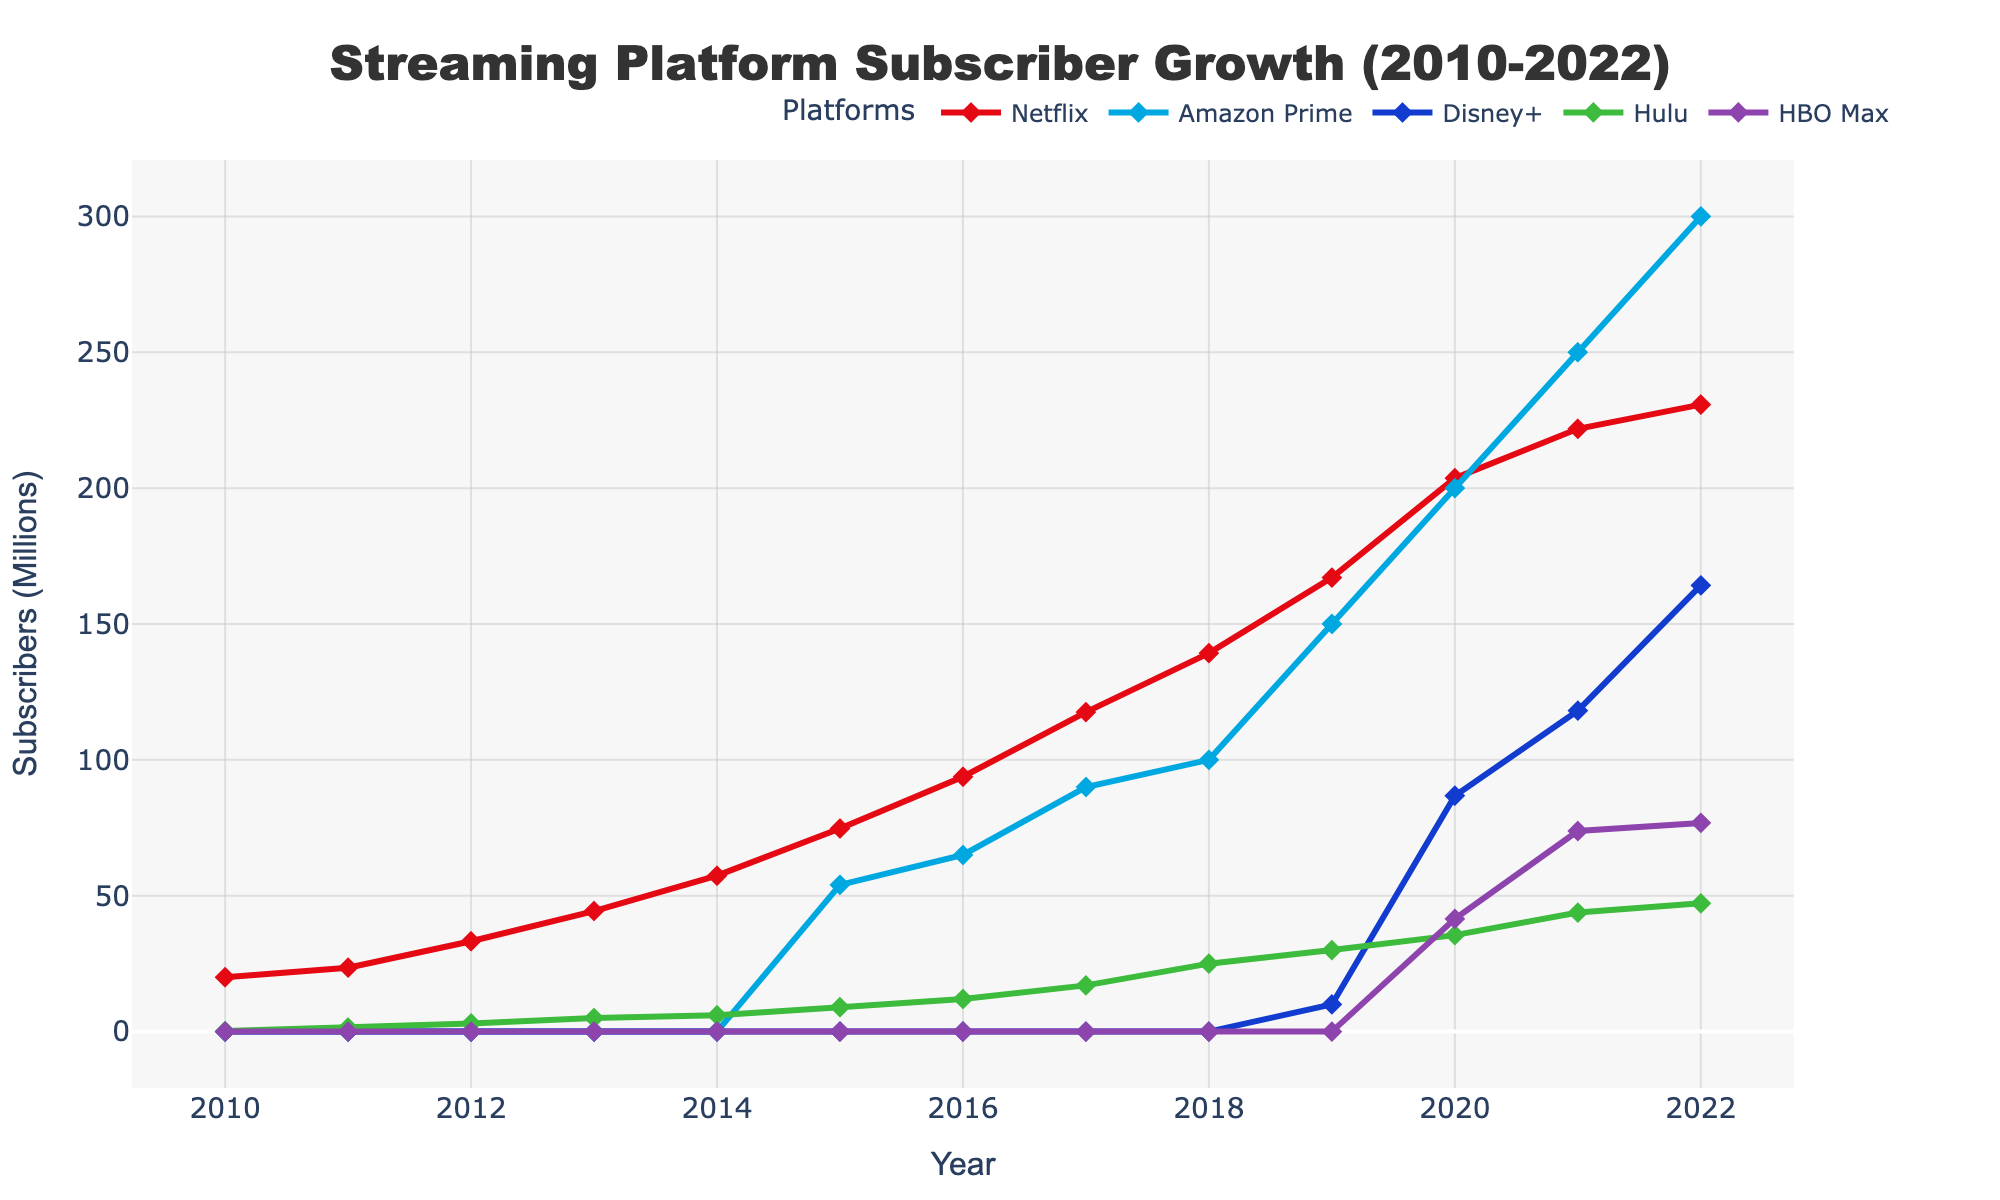What year did Disney+ surpass 100 million subscribers? Disney+ surpassed 100 million subscribers around 2021, based on the sharp increase in its subscriber count in that year.
Answer: 2021 How many subscribers did Hulu have in 2014? According to the figure, Hulu had approximately 6 million subscribers in 2014.
Answer: 6 million Between 2015 and 2022, which streaming platform experienced the largest increase in subscribers? By comparing the subscriber counts from 2015 to 2022, Netflix had an increase of approximately 156 million (230.75 - 74.76), Amazon Prime increased by about 246 million (300 - 54), Disney+ had the most significant absolute increase since it started in 2019, from 0 to 164.2 million.
Answer: Disney+ Which year shows the largest single-year growth for Netflix? By observing the slopes of the Netflix line, the steepest increase between two consecutive years is seen between 2018 and 2019 when it went from approximately 139.26 million to 167.09 million.
Answer: 2018-2019 Which platform had zero subscribers until 2019? The figure shows that Disney+ had zero subscribers until 2019, when it shows a rapid increase.
Answer: Disney+ What is the difference in subscriber count between Netflix and HBO Max in 2021? In 2021, Netflix had approximately 221.84 million subscribers, and HBO Max had about 73.8 million. The difference is 221.84 - 73.8 = 148.04 million.
Answer: 148.04 million Which platform was the first to surpass 200 million subscribers, and in which year did it happen? The figure indicates that Netflix was the first to surpass 200 million subscribers, which occurred in 2020.
Answer: Netflix, 2020 In which year did Amazon Prime overtake Netflix in terms of the rate of growth? By noticing the slope of the lines, Amazon Prime's growth rate appeared to surpass Netflix around 2020 when both lines began to show steeper slopes but Amazon Prime's increase was more pronounced.
Answer: 2020 How many subscribers did Hulu gain between 2012 and 2022? In 2012, Hulu had approximately 3 million subscribers. By 2022, it had about 47.2 million. The gain over the period is 47.2 - 3 = 44.2 million.
Answer: 44.2 million 